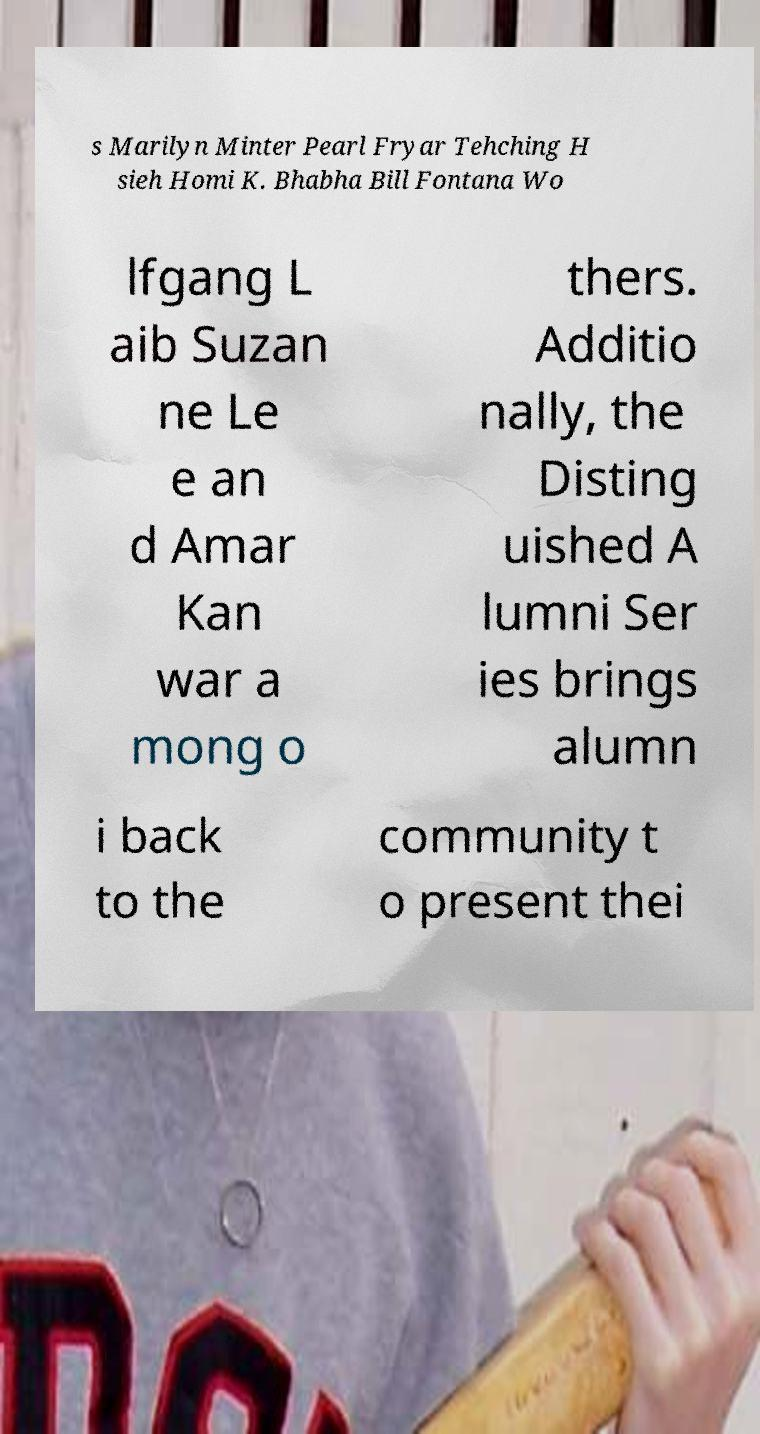Please read and relay the text visible in this image. What does it say? s Marilyn Minter Pearl Fryar Tehching H sieh Homi K. Bhabha Bill Fontana Wo lfgang L aib Suzan ne Le e an d Amar Kan war a mong o thers. Additio nally, the Disting uished A lumni Ser ies brings alumn i back to the community t o present thei 